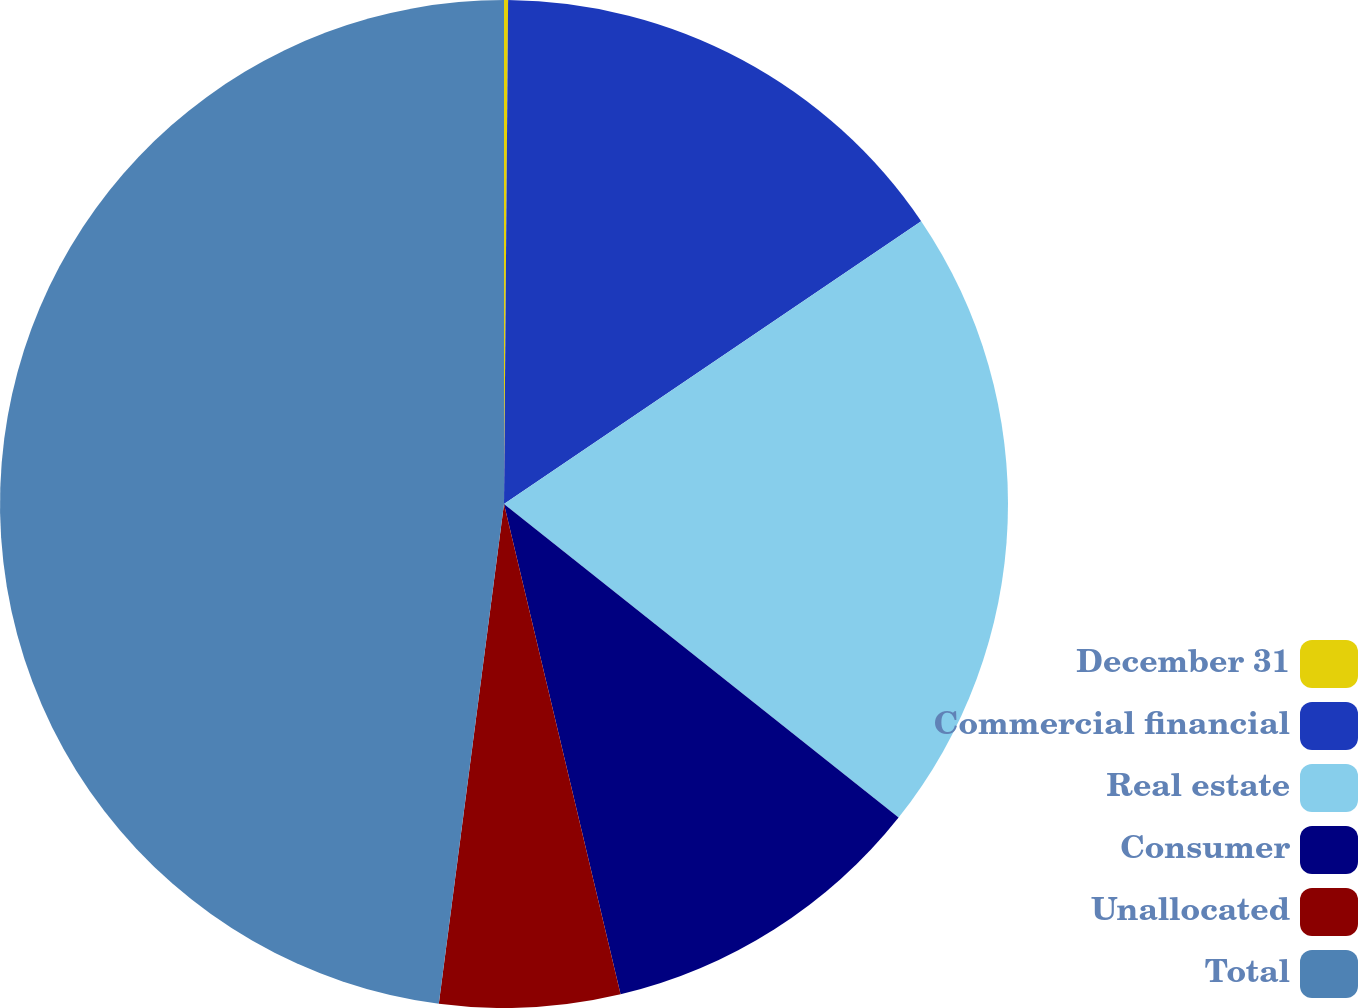<chart> <loc_0><loc_0><loc_500><loc_500><pie_chart><fcel>December 31<fcel>Commercial financial<fcel>Real estate<fcel>Consumer<fcel>Unallocated<fcel>Total<nl><fcel>0.13%<fcel>15.39%<fcel>20.17%<fcel>10.6%<fcel>5.78%<fcel>47.94%<nl></chart> 